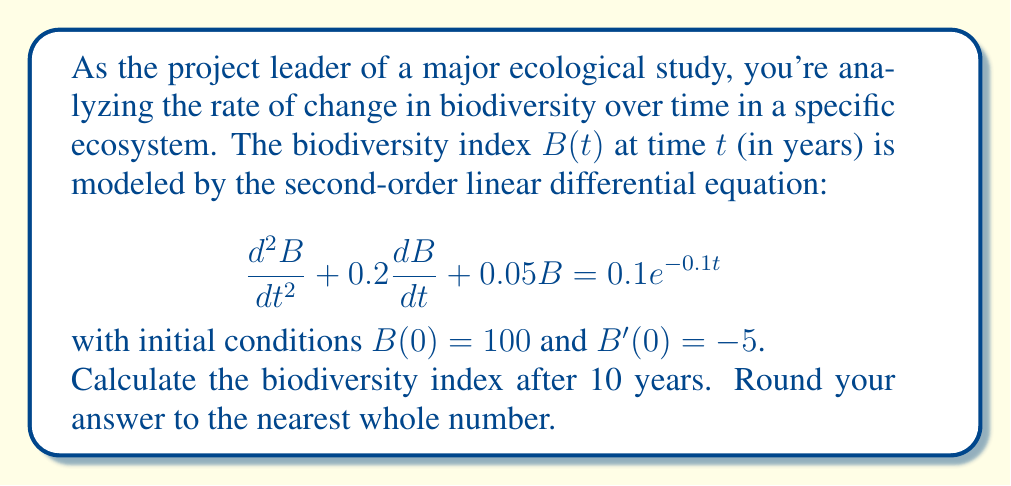Teach me how to tackle this problem. To solve this problem, we'll follow these steps:

1) First, we need to find the general solution of the homogeneous equation:
   $$\frac{d^2B}{dt^2} + 0.2\frac{dB}{dt} + 0.05B = 0$$
   
   The characteristic equation is $r^2 + 0.2r + 0.05 = 0$
   Solving this, we get $r_1 = -0.1 + 0.2i$ and $r_2 = -0.1 - 0.2i$

   So, the homogeneous solution is:
   $$B_h(t) = e^{-0.1t}(c_1\cos(0.2t) + c_2\sin(0.2t))$$

2) Now, we need to find a particular solution. Let's try $B_p(t) = Ae^{-0.1t}$
   Substituting this into the original equation:
   $$0.01Ae^{-0.1t} - 0.02Ae^{-0.1t} + 0.05Ae^{-0.1t} = 0.1e^{-0.1t}$$
   $$0.04Ae^{-0.1t} = 0.1e^{-0.1t}$$
   $$A = 2.5$$

   So, $B_p(t) = 2.5e^{-0.1t}$

3) The general solution is $B(t) = B_h(t) + B_p(t)$:
   $$B(t) = e^{-0.1t}(c_1\cos(0.2t) + c_2\sin(0.2t)) + 2.5e^{-0.1t}$$

4) Now we use the initial conditions to find $c_1$ and $c_2$:
   $B(0) = 100$: $c_1 + 2.5 = 100$, so $c_1 = 97.5$
   
   $B'(0) = -5$: $-0.1c_1 + 0.2c_2 - 0.25 = -5$
   Substituting $c_1 = 97.5$: $0.2c_2 = -5 + 0.1(97.5) + 0.25 = 5$
   So, $c_2 = 25$

5) Therefore, the specific solution is:
   $$B(t) = e^{-0.1t}(97.5\cos(0.2t) + 25\sin(0.2t)) + 2.5e^{-0.1t}$$

6) To find $B(10)$, we substitute $t = 10$:
   $$B(10) = e^{-1}(97.5\cos(2) + 25\sin(2)) + 2.5e^{-1}$$

7) Calculating this:
   $$B(10) \approx 0.368 * (97.5 * (-0.416) + 25 * 0.909) + 0.368 * 2.5$$
   $$B(10) \approx 0.368 * (-40.56 + 22.725) + 0.92$$
   $$B(10) \approx -6.56 + 0.92 \approx -5.64$$

8) Rounding to the nearest whole number: $B(10) \approx -6$
Answer: -6 